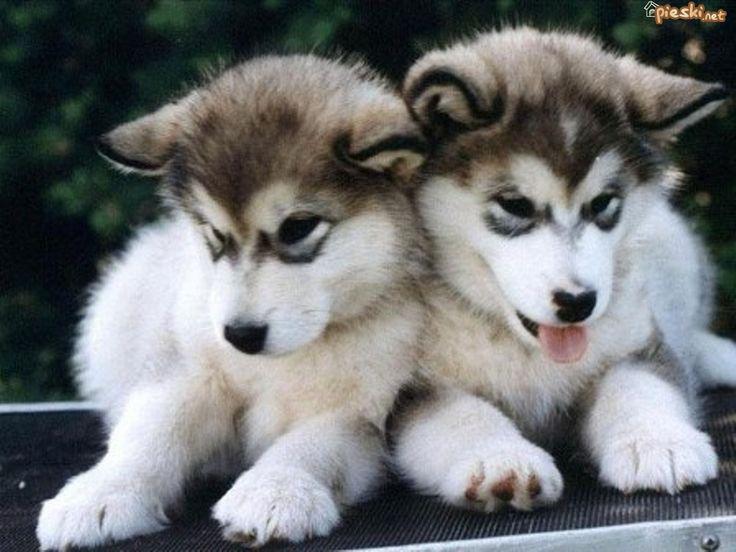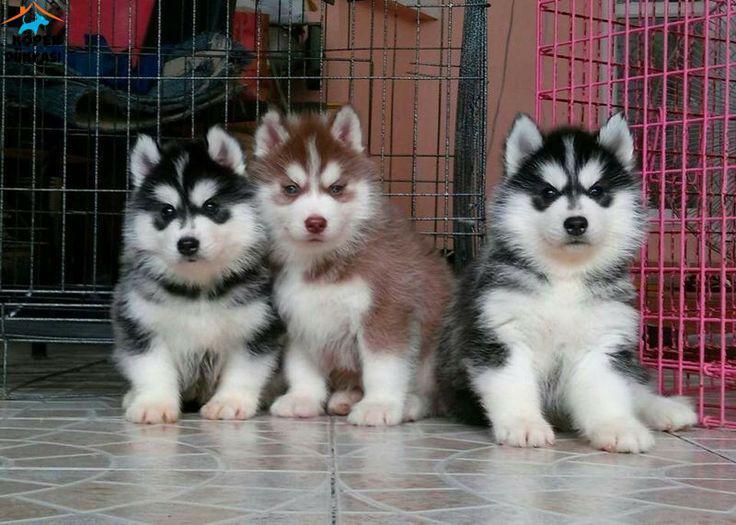The first image is the image on the left, the second image is the image on the right. Evaluate the accuracy of this statement regarding the images: "There are exactly two dogs.". Is it true? Answer yes or no. No. 